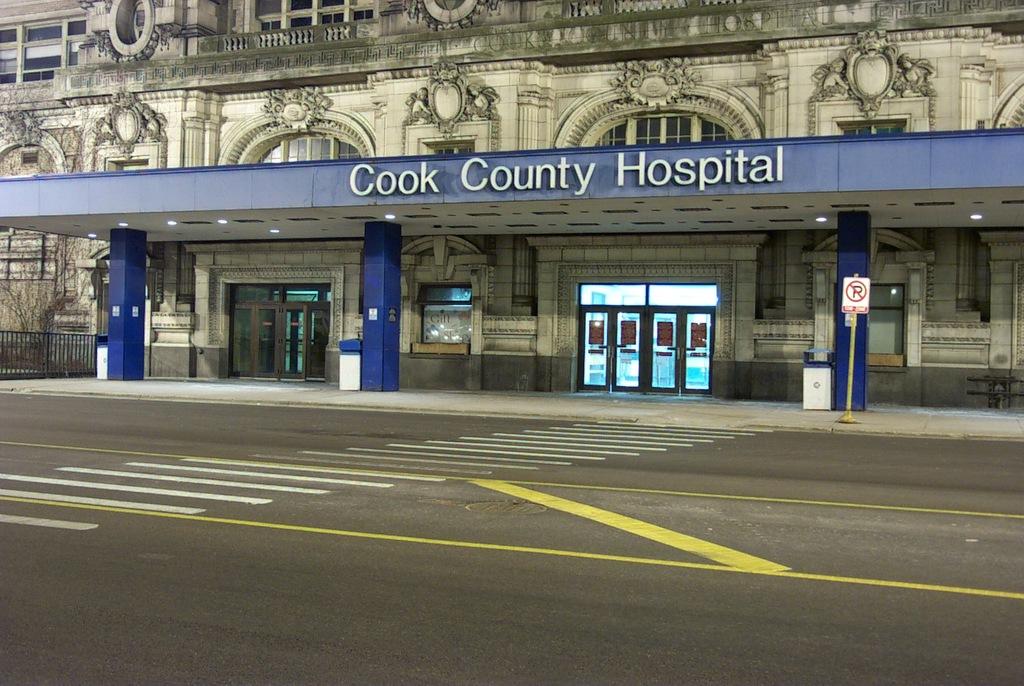This is petrol bunk hospital?
Your answer should be compact. No. Where is this hospital?
Offer a very short reply. Cook county. 